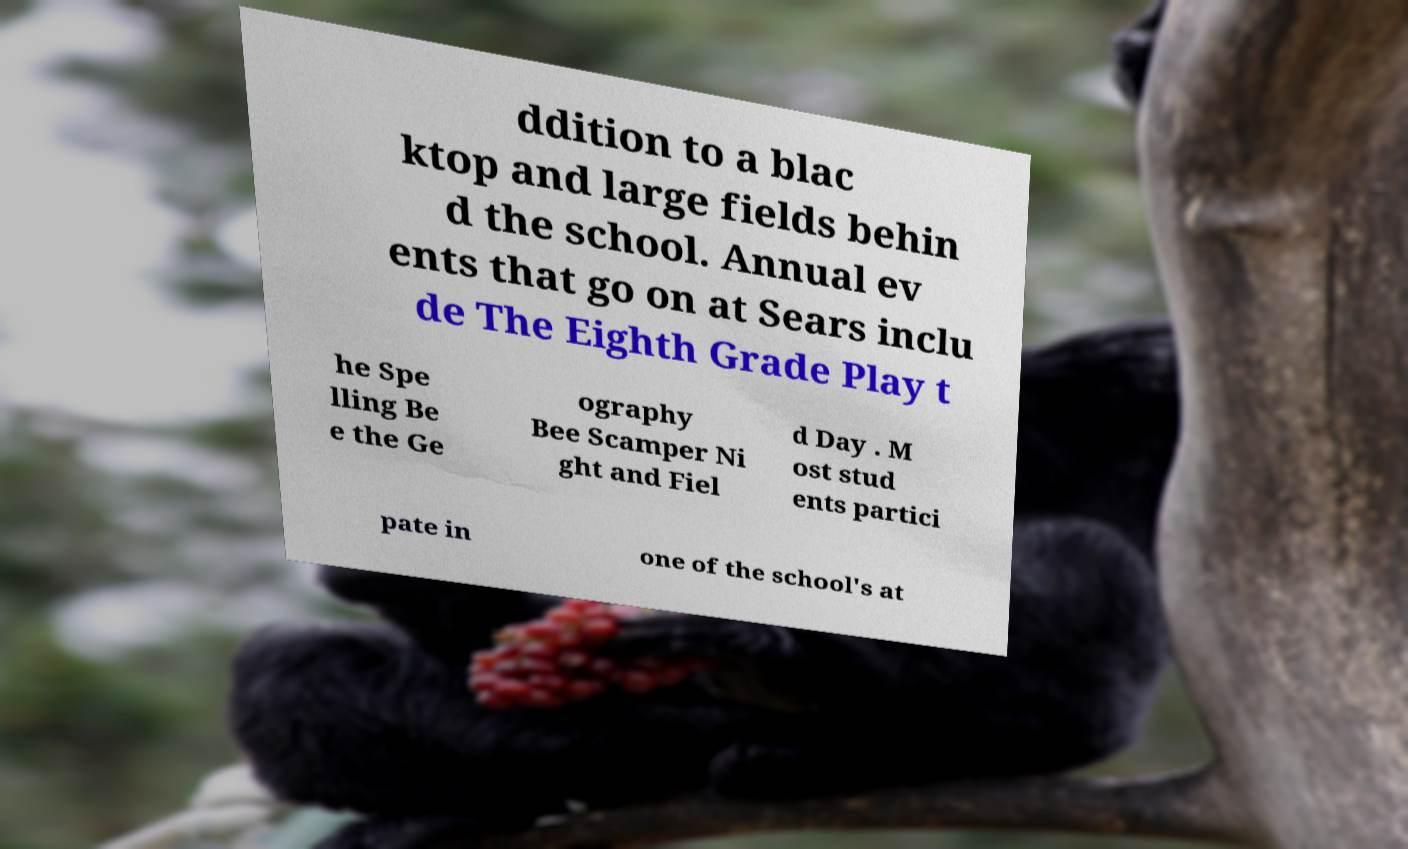Could you assist in decoding the text presented in this image and type it out clearly? ddition to a blac ktop and large fields behin d the school. Annual ev ents that go on at Sears inclu de The Eighth Grade Play t he Spe lling Be e the Ge ography Bee Scamper Ni ght and Fiel d Day . M ost stud ents partici pate in one of the school's at 